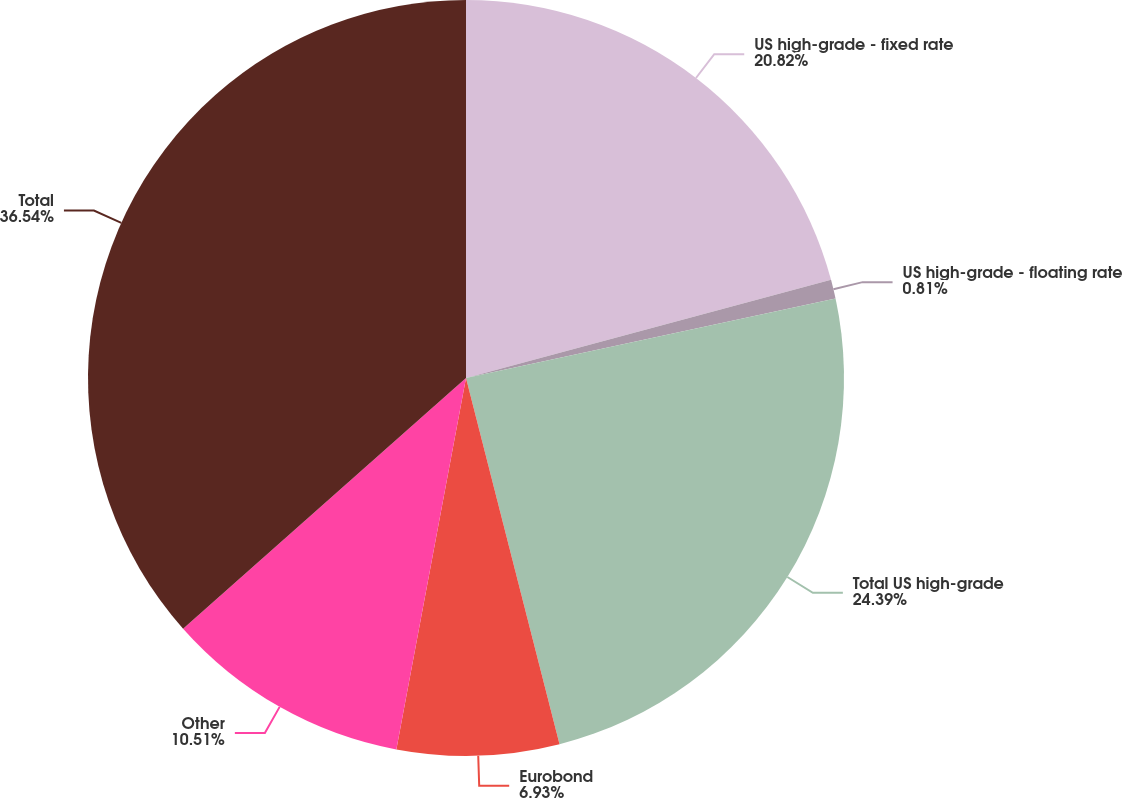Convert chart to OTSL. <chart><loc_0><loc_0><loc_500><loc_500><pie_chart><fcel>US high-grade - fixed rate<fcel>US high-grade - floating rate<fcel>Total US high-grade<fcel>Eurobond<fcel>Other<fcel>Total<nl><fcel>20.82%<fcel>0.81%<fcel>24.39%<fcel>6.93%<fcel>10.51%<fcel>36.54%<nl></chart> 